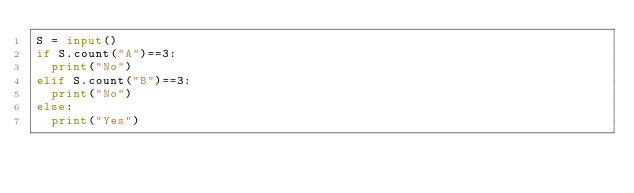Convert code to text. <code><loc_0><loc_0><loc_500><loc_500><_Python_>S = input()
if S.count("A")==3:
  print("No")
elif S.count("B")==3:
  print("No")
else:
  print("Yes")</code> 